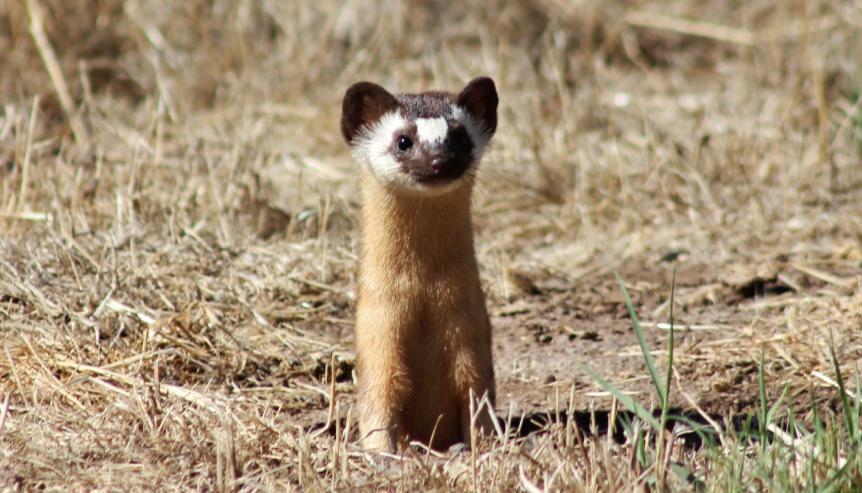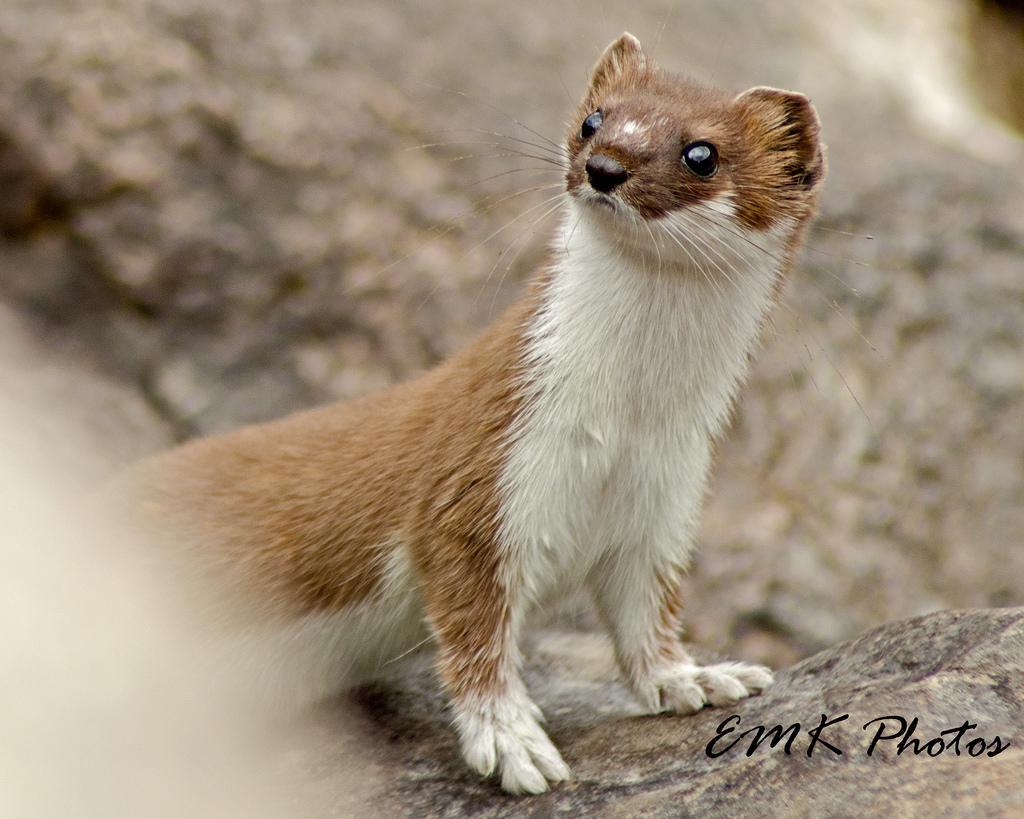The first image is the image on the left, the second image is the image on the right. For the images displayed, is the sentence "A single animal is poking its head out from the ground." factually correct? Answer yes or no. Yes. The first image is the image on the left, the second image is the image on the right. Given the left and right images, does the statement "Each image shows a single ferret, with its head held upright." hold true? Answer yes or no. Yes. 